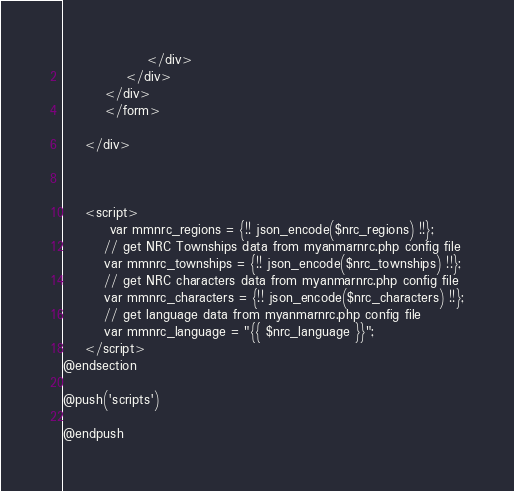Convert code to text. <code><loc_0><loc_0><loc_500><loc_500><_PHP_>                </div>
            </div>
        </div>
        </form>

    </div>



    <script>
         var mmnrc_regions = {!! json_encode($nrc_regions) !!};
        // get NRC Townships data from myanmarnrc.php config file
        var mmnrc_townships = {!! json_encode($nrc_townships) !!};
        // get NRC characters data from myanmarnrc.php config file
        var mmnrc_characters = {!! json_encode($nrc_characters) !!};
        // get language data from myanmarnrc.php config file
        var mmnrc_language = "{{ $nrc_language }}";
    </script>
@endsection

@push('scripts')

@endpush
</code> 